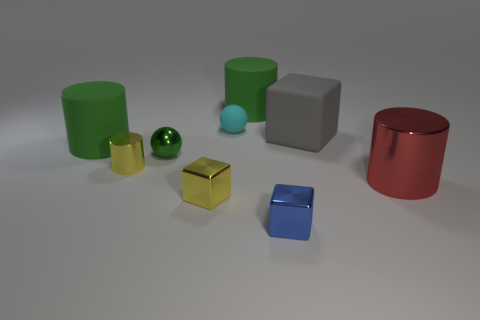Subtract all small blue shiny cubes. How many cubes are left? 2 Subtract all cyan blocks. How many green cylinders are left? 2 Add 1 shiny things. How many objects exist? 10 Subtract all yellow cubes. How many cubes are left? 2 Subtract all cubes. How many objects are left? 6 Subtract 2 blocks. How many blocks are left? 1 Subtract all cylinders. Subtract all big objects. How many objects are left? 1 Add 5 blue blocks. How many blue blocks are left? 6 Add 4 tiny matte cubes. How many tiny matte cubes exist? 4 Subtract 1 red cylinders. How many objects are left? 8 